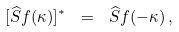Convert formula to latex. <formula><loc_0><loc_0><loc_500><loc_500>[ \widehat { S } f ( \kappa ) ] ^ { * } \ = \ \widehat { S } f ( - \kappa ) \, ,</formula> 